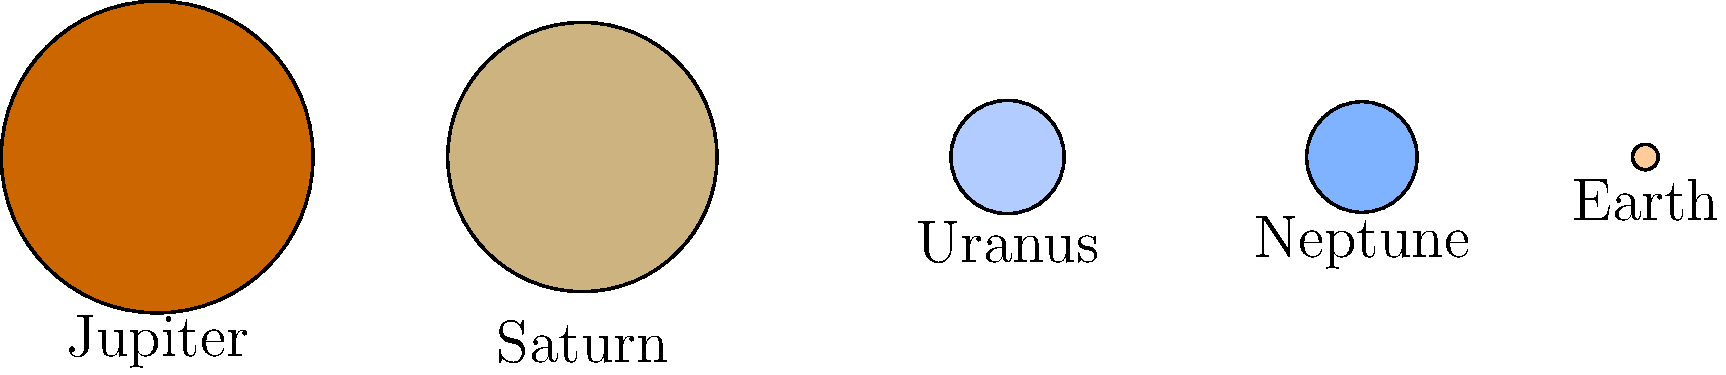As a parent who often discusses space with your child, you come across this diagram showing the relative sizes of some planets in our solar system. Which planet is represented as the largest in this scale drawing? To determine which planet is represented as the largest in this scale drawing, we need to compare the sizes of the circles representing each planet. Let's go through this step-by-step:

1. First, we can see that there are five planets represented in the diagram: Jupiter, Saturn, Uranus, Neptune, and Earth.

2. The size of each planet is represented by the diameter of its corresponding circle.

3. Looking at the diagram, we can easily see that the two largest circles represent Jupiter and Saturn.

4. Comparing these two largest circles:
   - Jupiter's circle appears slightly larger than Saturn's.
   - Jupiter's circle has a reddish-orange color, while Saturn's is more of a pale yellow.

5. The other planets (Uranus, Neptune, and Earth) are represented by much smaller circles, so we can disregard them in determining the largest.

6. In reality, Jupiter is indeed the largest planet in our solar system, so this representation is accurate.

Therefore, based on the scale drawing provided, Jupiter is represented as the largest planet.
Answer: Jupiter 